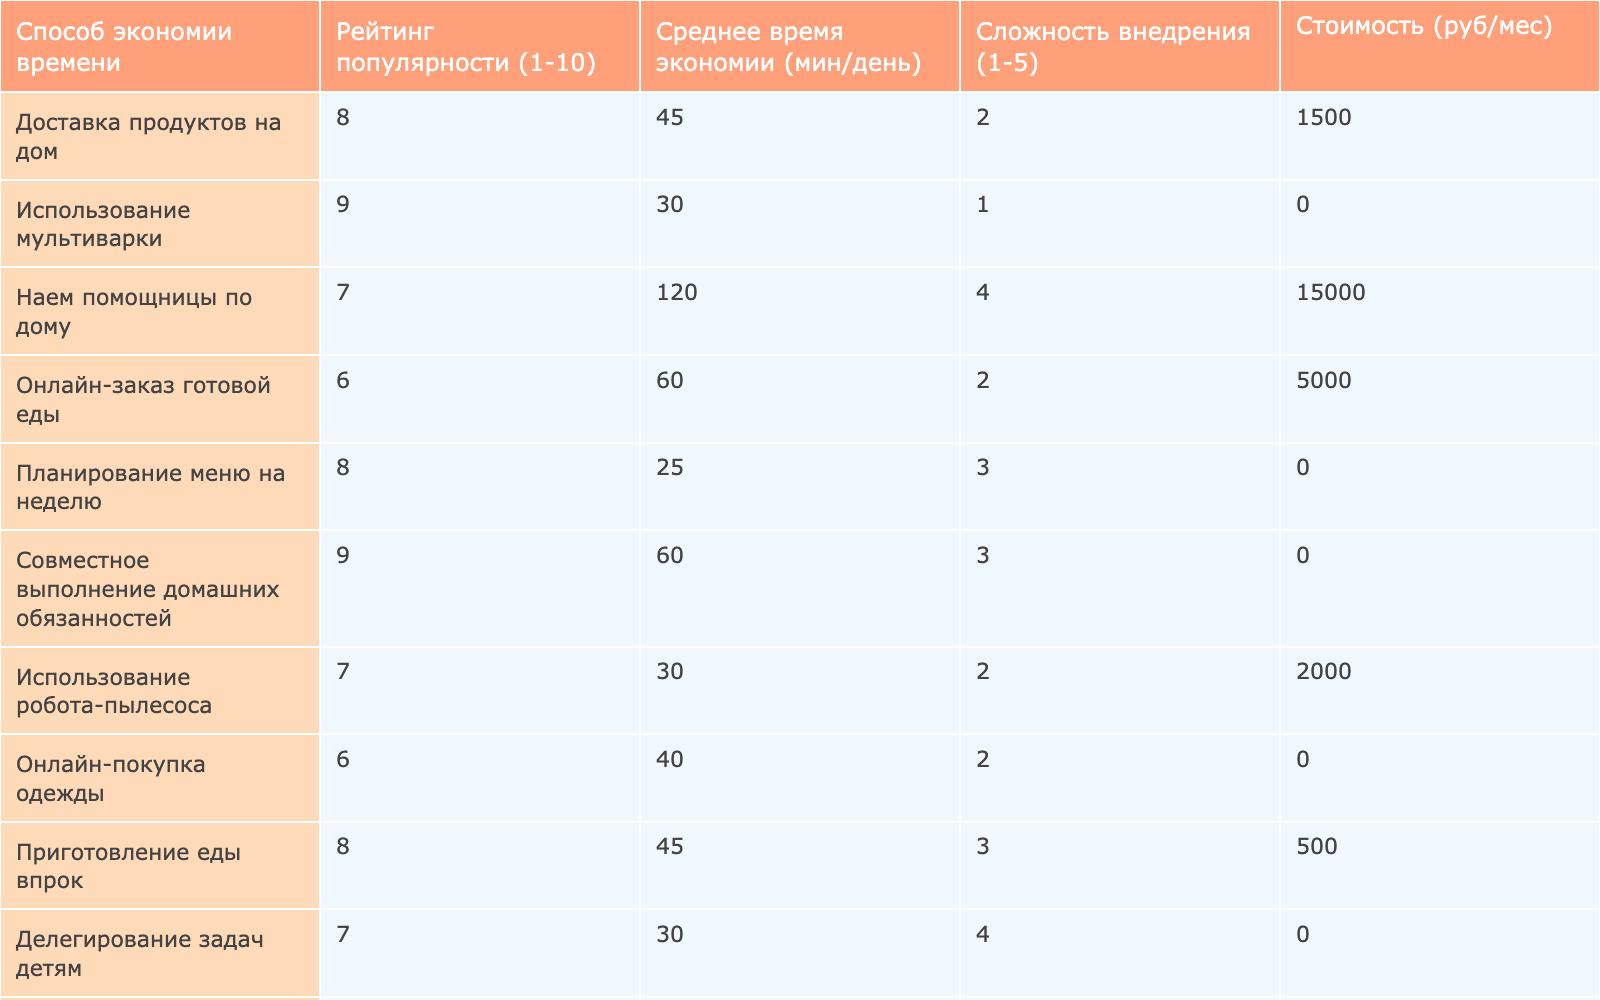What is the highest popularity rating among the time-saving methods? The table lists ratings from 1 to 10. Upon inspection, the method "Использование мультиварки" has the highest rating of 9.
Answer: 9 Which method has the least average time saved per day? The method "Заказ химчистки с доставкой" saves 25 minutes on average per day, which is the lowest value in the table.
Answer: 25 How many methods have a popularity rating of 8 or higher? The methods are: "Использование мультиварки", "Планирование меню на неделю", "Совместное выполнение домашних обязанностей", "Онлайн-банкинг и оплата счетов", and "Удаленная работа", making a total of 5.
Answer: 5 What is the total average time saved when using methods rated 7 or above? The methods rated 7 or above are "Использование мультиварки" (30), "Доставка продуктов на дом" (45), "Совместное выполнение домашних обязанностей" (60), "Приготовление еды впрок" (45), "Удаленная работа" (90), "Наем помощницы по дому" (120). Their total is 30 + 45 + 60 + 45 + 90 + 120 = 390, and since there are 6 methods, the average is 390/6 = 65.
Answer: 65 Is there any method that costs less than 1500 rubles per month? Yes, there are several methods like "Использование мультиварки", "Планирование меню на неделю", "Делегирование задач детям", and "Онлайн-банкинг и оплата счетов", all of which have a cost of 0 rubles, which is definitely less than 1500.
Answer: Yes What is the average complexity of methods rated 6 or below? The methods rated 6 or below are "Наем помощницы по дому" (4), "Онлайн-заказ готовой еды" (2), "Использование службы глажки" (2), "Онлайн-покупка одежды" (2), and "Заказ химчистки с доставкой" (2). Their complexity values sum to 4 + 2 + 2 + 2 + 2 = 12, and there are 5 methods, thus the average complexity is 12/5 = 2.4.
Answer: 2.4 What method provides the highest average time savings while being zero in cost? The method "Планирование меню на неделю" saves an average of 25 minutes daily, while "Онлайн-банкинг и оплата счетов" saves 20 minutes, and "Делегирование задач детям" and "Совместное выполнение домашних обязанностей" both save 60 minutes, making 60 the highest among them.
Answer: 60 How does the complexity of "Удаленная работа" compare to other time-saving methods? "Удаленная работа" has a complexity rating of 4, which is higher than most; only "Наем помощницы по дому" (4) matches it, while others generally range from 1 to 3.
Answer: Higher than most methods 